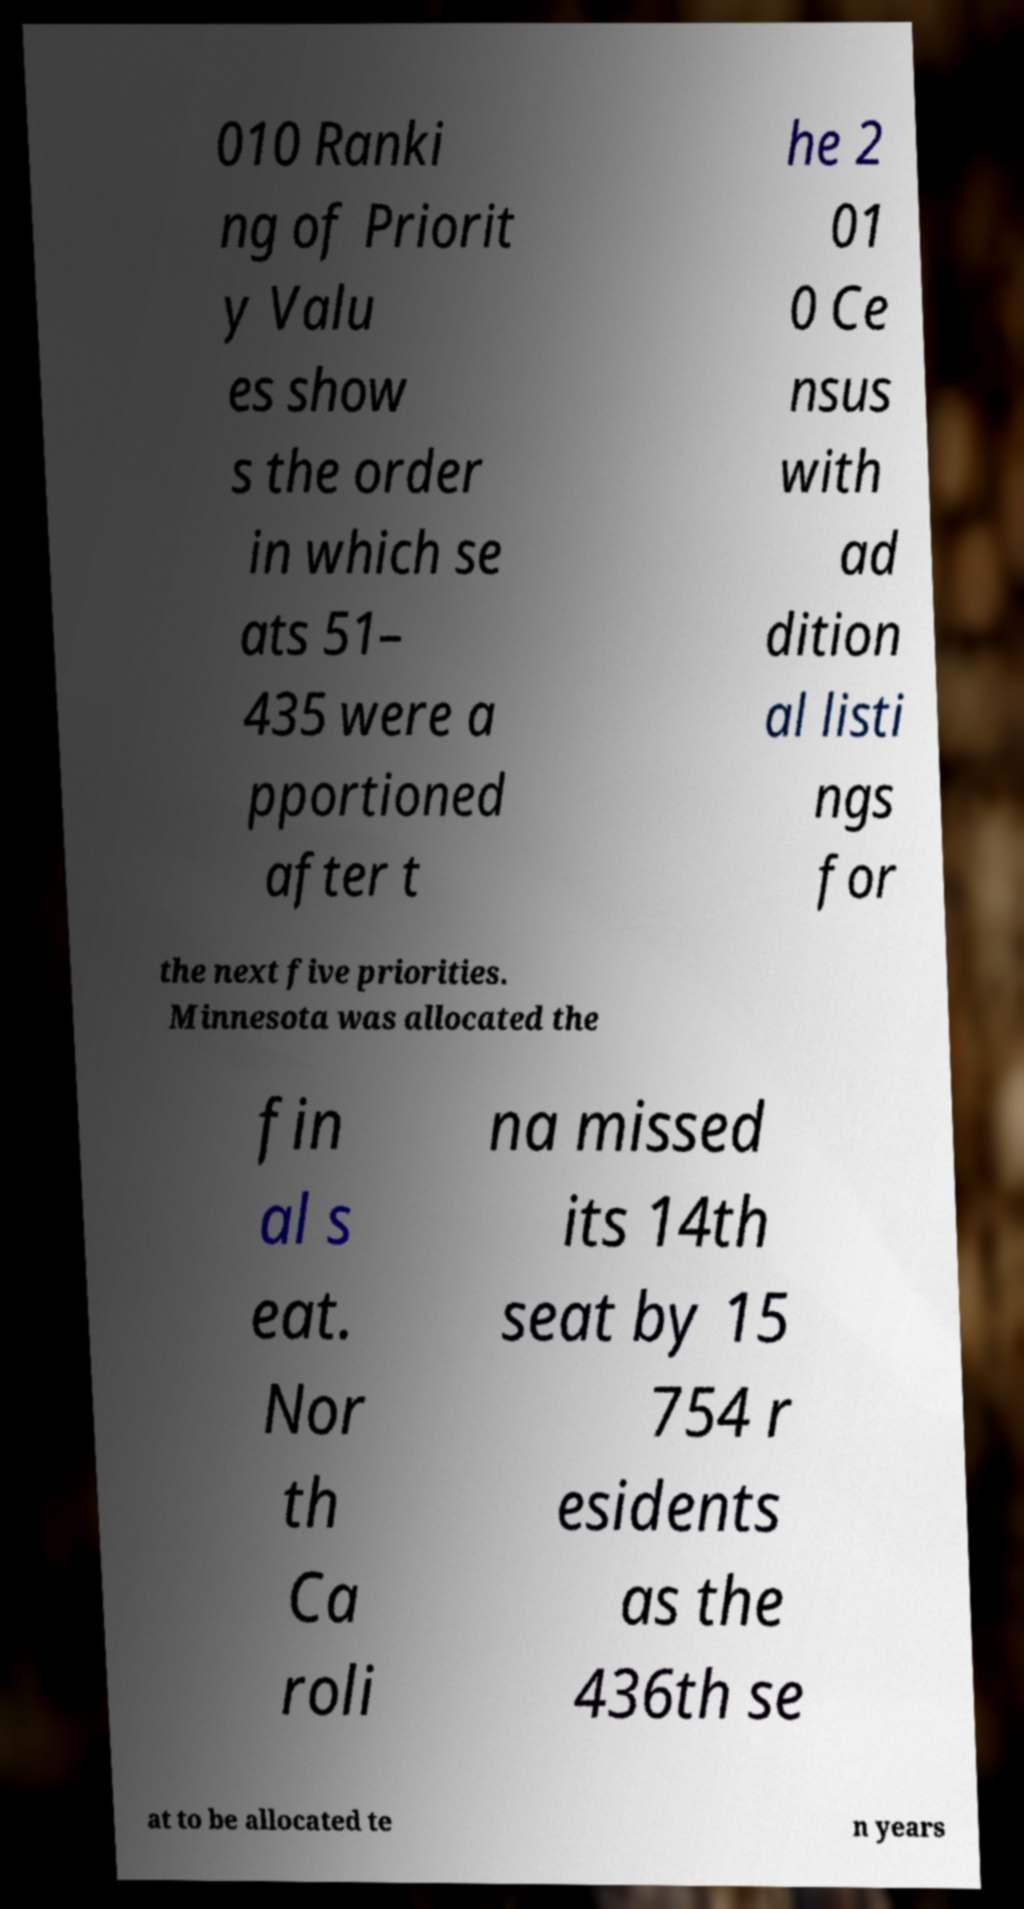For documentation purposes, I need the text within this image transcribed. Could you provide that? 010 Ranki ng of Priorit y Valu es show s the order in which se ats 51– 435 were a pportioned after t he 2 01 0 Ce nsus with ad dition al listi ngs for the next five priorities. Minnesota was allocated the fin al s eat. Nor th Ca roli na missed its 14th seat by 15 754 r esidents as the 436th se at to be allocated te n years 